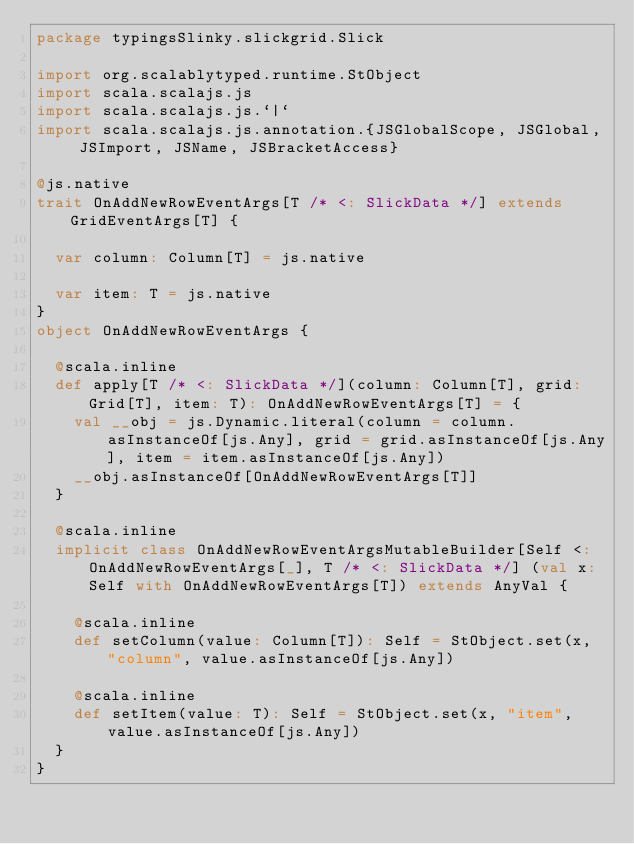Convert code to text. <code><loc_0><loc_0><loc_500><loc_500><_Scala_>package typingsSlinky.slickgrid.Slick

import org.scalablytyped.runtime.StObject
import scala.scalajs.js
import scala.scalajs.js.`|`
import scala.scalajs.js.annotation.{JSGlobalScope, JSGlobal, JSImport, JSName, JSBracketAccess}

@js.native
trait OnAddNewRowEventArgs[T /* <: SlickData */] extends GridEventArgs[T] {
  
  var column: Column[T] = js.native
  
  var item: T = js.native
}
object OnAddNewRowEventArgs {
  
  @scala.inline
  def apply[T /* <: SlickData */](column: Column[T], grid: Grid[T], item: T): OnAddNewRowEventArgs[T] = {
    val __obj = js.Dynamic.literal(column = column.asInstanceOf[js.Any], grid = grid.asInstanceOf[js.Any], item = item.asInstanceOf[js.Any])
    __obj.asInstanceOf[OnAddNewRowEventArgs[T]]
  }
  
  @scala.inline
  implicit class OnAddNewRowEventArgsMutableBuilder[Self <: OnAddNewRowEventArgs[_], T /* <: SlickData */] (val x: Self with OnAddNewRowEventArgs[T]) extends AnyVal {
    
    @scala.inline
    def setColumn(value: Column[T]): Self = StObject.set(x, "column", value.asInstanceOf[js.Any])
    
    @scala.inline
    def setItem(value: T): Self = StObject.set(x, "item", value.asInstanceOf[js.Any])
  }
}
</code> 